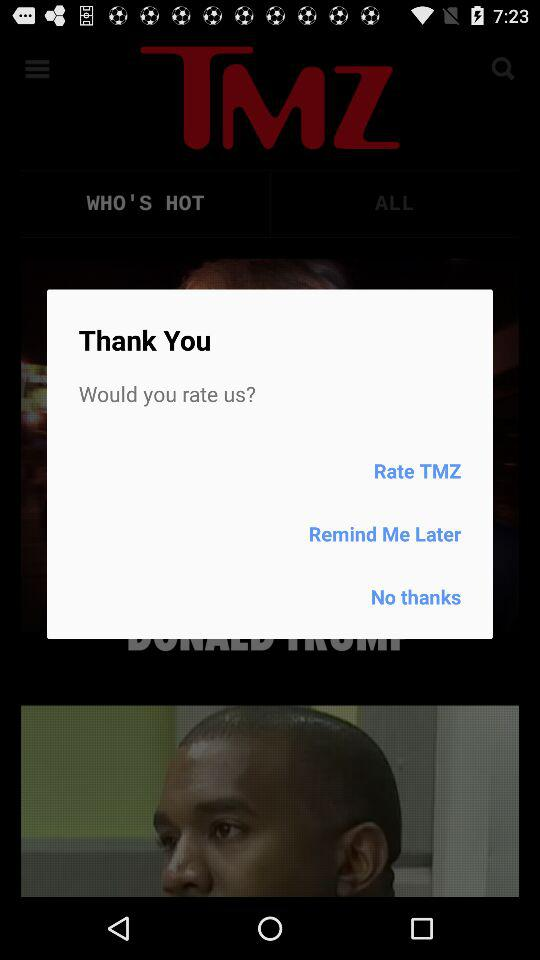What is the name of the application? The name of the application is "TMZ". 